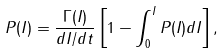Convert formula to latex. <formula><loc_0><loc_0><loc_500><loc_500>P ( I ) = \frac { \Gamma ( I ) } { d I / d t } \left [ 1 - \int ^ { I } _ { 0 } P ( I ) d I \right ] ,</formula> 